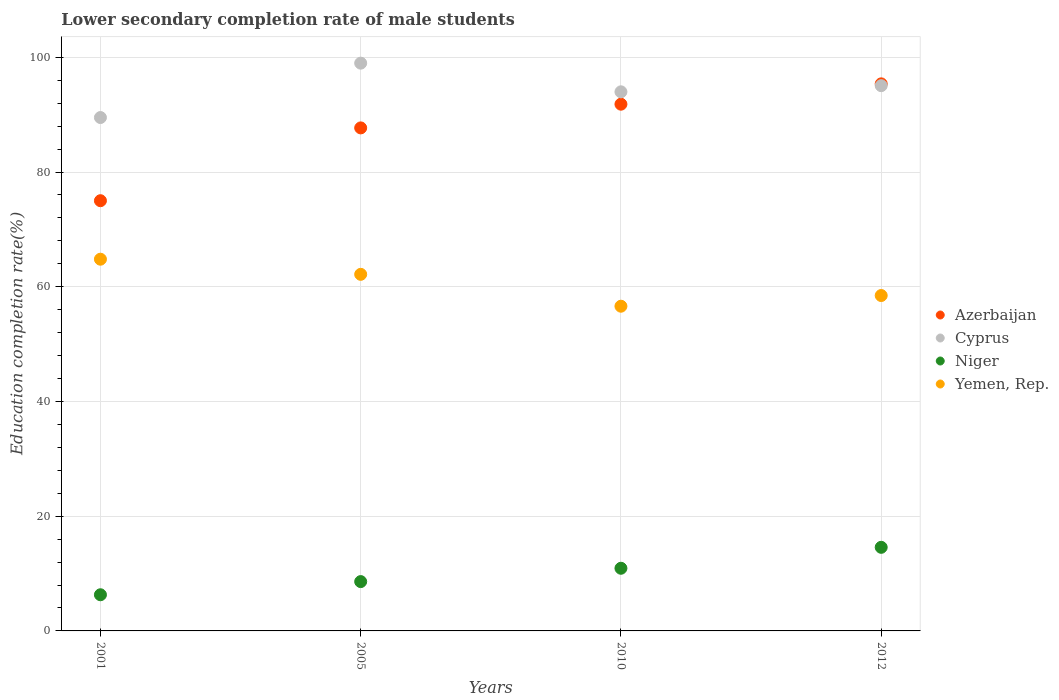What is the lower secondary completion rate of male students in Cyprus in 2001?
Give a very brief answer. 89.5. Across all years, what is the maximum lower secondary completion rate of male students in Yemen, Rep.?
Offer a very short reply. 64.8. Across all years, what is the minimum lower secondary completion rate of male students in Yemen, Rep.?
Ensure brevity in your answer.  56.61. In which year was the lower secondary completion rate of male students in Niger maximum?
Offer a very short reply. 2012. In which year was the lower secondary completion rate of male students in Yemen, Rep. minimum?
Your answer should be compact. 2010. What is the total lower secondary completion rate of male students in Yemen, Rep. in the graph?
Give a very brief answer. 242.05. What is the difference between the lower secondary completion rate of male students in Yemen, Rep. in 2005 and that in 2010?
Offer a very short reply. 5.56. What is the difference between the lower secondary completion rate of male students in Cyprus in 2005 and the lower secondary completion rate of male students in Yemen, Rep. in 2012?
Make the answer very short. 40.51. What is the average lower secondary completion rate of male students in Cyprus per year?
Offer a very short reply. 94.38. In the year 2005, what is the difference between the lower secondary completion rate of male students in Niger and lower secondary completion rate of male students in Cyprus?
Provide a short and direct response. -90.38. What is the ratio of the lower secondary completion rate of male students in Niger in 2001 to that in 2012?
Make the answer very short. 0.43. Is the difference between the lower secondary completion rate of male students in Niger in 2001 and 2010 greater than the difference between the lower secondary completion rate of male students in Cyprus in 2001 and 2010?
Give a very brief answer. No. What is the difference between the highest and the second highest lower secondary completion rate of male students in Azerbaijan?
Provide a short and direct response. 3.55. What is the difference between the highest and the lowest lower secondary completion rate of male students in Yemen, Rep.?
Your response must be concise. 8.2. In how many years, is the lower secondary completion rate of male students in Cyprus greater than the average lower secondary completion rate of male students in Cyprus taken over all years?
Offer a terse response. 2. Is the sum of the lower secondary completion rate of male students in Niger in 2010 and 2012 greater than the maximum lower secondary completion rate of male students in Azerbaijan across all years?
Provide a succinct answer. No. Is it the case that in every year, the sum of the lower secondary completion rate of male students in Yemen, Rep. and lower secondary completion rate of male students in Azerbaijan  is greater than the sum of lower secondary completion rate of male students in Cyprus and lower secondary completion rate of male students in Niger?
Keep it short and to the point. No. Does the lower secondary completion rate of male students in Cyprus monotonically increase over the years?
Make the answer very short. No. How many dotlines are there?
Offer a terse response. 4. How many years are there in the graph?
Give a very brief answer. 4. Does the graph contain any zero values?
Offer a very short reply. No. Does the graph contain grids?
Offer a terse response. Yes. Where does the legend appear in the graph?
Give a very brief answer. Center right. How many legend labels are there?
Provide a succinct answer. 4. How are the legend labels stacked?
Your answer should be compact. Vertical. What is the title of the graph?
Give a very brief answer. Lower secondary completion rate of male students. What is the label or title of the X-axis?
Ensure brevity in your answer.  Years. What is the label or title of the Y-axis?
Offer a very short reply. Education completion rate(%). What is the Education completion rate(%) in Cyprus in 2001?
Make the answer very short. 89.5. What is the Education completion rate(%) of Niger in 2001?
Provide a short and direct response. 6.3. What is the Education completion rate(%) of Yemen, Rep. in 2001?
Provide a short and direct response. 64.8. What is the Education completion rate(%) in Azerbaijan in 2005?
Offer a terse response. 87.69. What is the Education completion rate(%) of Cyprus in 2005?
Offer a very short reply. 98.98. What is the Education completion rate(%) of Niger in 2005?
Offer a very short reply. 8.6. What is the Education completion rate(%) of Yemen, Rep. in 2005?
Provide a short and direct response. 62.17. What is the Education completion rate(%) in Azerbaijan in 2010?
Provide a short and direct response. 91.83. What is the Education completion rate(%) in Cyprus in 2010?
Provide a short and direct response. 93.98. What is the Education completion rate(%) in Niger in 2010?
Your answer should be very brief. 10.92. What is the Education completion rate(%) in Yemen, Rep. in 2010?
Keep it short and to the point. 56.61. What is the Education completion rate(%) in Azerbaijan in 2012?
Ensure brevity in your answer.  95.37. What is the Education completion rate(%) of Cyprus in 2012?
Keep it short and to the point. 95.06. What is the Education completion rate(%) in Niger in 2012?
Provide a succinct answer. 14.57. What is the Education completion rate(%) of Yemen, Rep. in 2012?
Offer a very short reply. 58.47. Across all years, what is the maximum Education completion rate(%) of Azerbaijan?
Your answer should be very brief. 95.37. Across all years, what is the maximum Education completion rate(%) of Cyprus?
Keep it short and to the point. 98.98. Across all years, what is the maximum Education completion rate(%) in Niger?
Your answer should be very brief. 14.57. Across all years, what is the maximum Education completion rate(%) of Yemen, Rep.?
Your answer should be very brief. 64.8. Across all years, what is the minimum Education completion rate(%) in Cyprus?
Offer a very short reply. 89.5. Across all years, what is the minimum Education completion rate(%) in Niger?
Offer a terse response. 6.3. Across all years, what is the minimum Education completion rate(%) of Yemen, Rep.?
Make the answer very short. 56.61. What is the total Education completion rate(%) of Azerbaijan in the graph?
Keep it short and to the point. 349.89. What is the total Education completion rate(%) in Cyprus in the graph?
Your answer should be compact. 377.52. What is the total Education completion rate(%) of Niger in the graph?
Ensure brevity in your answer.  40.4. What is the total Education completion rate(%) of Yemen, Rep. in the graph?
Offer a very short reply. 242.05. What is the difference between the Education completion rate(%) in Azerbaijan in 2001 and that in 2005?
Provide a short and direct response. -12.69. What is the difference between the Education completion rate(%) of Cyprus in 2001 and that in 2005?
Provide a short and direct response. -9.48. What is the difference between the Education completion rate(%) in Niger in 2001 and that in 2005?
Keep it short and to the point. -2.29. What is the difference between the Education completion rate(%) in Yemen, Rep. in 2001 and that in 2005?
Offer a very short reply. 2.64. What is the difference between the Education completion rate(%) in Azerbaijan in 2001 and that in 2010?
Give a very brief answer. -16.83. What is the difference between the Education completion rate(%) of Cyprus in 2001 and that in 2010?
Ensure brevity in your answer.  -4.48. What is the difference between the Education completion rate(%) of Niger in 2001 and that in 2010?
Give a very brief answer. -4.62. What is the difference between the Education completion rate(%) of Yemen, Rep. in 2001 and that in 2010?
Provide a short and direct response. 8.2. What is the difference between the Education completion rate(%) in Azerbaijan in 2001 and that in 2012?
Keep it short and to the point. -20.37. What is the difference between the Education completion rate(%) of Cyprus in 2001 and that in 2012?
Keep it short and to the point. -5.55. What is the difference between the Education completion rate(%) in Niger in 2001 and that in 2012?
Keep it short and to the point. -8.27. What is the difference between the Education completion rate(%) of Yemen, Rep. in 2001 and that in 2012?
Make the answer very short. 6.33. What is the difference between the Education completion rate(%) of Azerbaijan in 2005 and that in 2010?
Make the answer very short. -4.13. What is the difference between the Education completion rate(%) of Cyprus in 2005 and that in 2010?
Offer a terse response. 5. What is the difference between the Education completion rate(%) in Niger in 2005 and that in 2010?
Make the answer very short. -2.33. What is the difference between the Education completion rate(%) of Yemen, Rep. in 2005 and that in 2010?
Make the answer very short. 5.56. What is the difference between the Education completion rate(%) in Azerbaijan in 2005 and that in 2012?
Give a very brief answer. -7.68. What is the difference between the Education completion rate(%) in Cyprus in 2005 and that in 2012?
Your answer should be compact. 3.92. What is the difference between the Education completion rate(%) in Niger in 2005 and that in 2012?
Ensure brevity in your answer.  -5.98. What is the difference between the Education completion rate(%) in Yemen, Rep. in 2005 and that in 2012?
Your response must be concise. 3.69. What is the difference between the Education completion rate(%) in Azerbaijan in 2010 and that in 2012?
Offer a terse response. -3.55. What is the difference between the Education completion rate(%) in Cyprus in 2010 and that in 2012?
Your answer should be compact. -1.07. What is the difference between the Education completion rate(%) of Niger in 2010 and that in 2012?
Keep it short and to the point. -3.65. What is the difference between the Education completion rate(%) of Yemen, Rep. in 2010 and that in 2012?
Your answer should be very brief. -1.86. What is the difference between the Education completion rate(%) of Azerbaijan in 2001 and the Education completion rate(%) of Cyprus in 2005?
Ensure brevity in your answer.  -23.98. What is the difference between the Education completion rate(%) in Azerbaijan in 2001 and the Education completion rate(%) in Niger in 2005?
Make the answer very short. 66.4. What is the difference between the Education completion rate(%) of Azerbaijan in 2001 and the Education completion rate(%) of Yemen, Rep. in 2005?
Ensure brevity in your answer.  12.83. What is the difference between the Education completion rate(%) of Cyprus in 2001 and the Education completion rate(%) of Niger in 2005?
Provide a short and direct response. 80.9. What is the difference between the Education completion rate(%) of Cyprus in 2001 and the Education completion rate(%) of Yemen, Rep. in 2005?
Your answer should be very brief. 27.34. What is the difference between the Education completion rate(%) in Niger in 2001 and the Education completion rate(%) in Yemen, Rep. in 2005?
Provide a succinct answer. -55.86. What is the difference between the Education completion rate(%) in Azerbaijan in 2001 and the Education completion rate(%) in Cyprus in 2010?
Offer a very short reply. -18.98. What is the difference between the Education completion rate(%) in Azerbaijan in 2001 and the Education completion rate(%) in Niger in 2010?
Your answer should be compact. 64.08. What is the difference between the Education completion rate(%) in Azerbaijan in 2001 and the Education completion rate(%) in Yemen, Rep. in 2010?
Make the answer very short. 18.39. What is the difference between the Education completion rate(%) in Cyprus in 2001 and the Education completion rate(%) in Niger in 2010?
Offer a very short reply. 78.58. What is the difference between the Education completion rate(%) in Cyprus in 2001 and the Education completion rate(%) in Yemen, Rep. in 2010?
Give a very brief answer. 32.89. What is the difference between the Education completion rate(%) of Niger in 2001 and the Education completion rate(%) of Yemen, Rep. in 2010?
Offer a very short reply. -50.3. What is the difference between the Education completion rate(%) in Azerbaijan in 2001 and the Education completion rate(%) in Cyprus in 2012?
Your answer should be very brief. -20.06. What is the difference between the Education completion rate(%) in Azerbaijan in 2001 and the Education completion rate(%) in Niger in 2012?
Give a very brief answer. 60.43. What is the difference between the Education completion rate(%) in Azerbaijan in 2001 and the Education completion rate(%) in Yemen, Rep. in 2012?
Provide a short and direct response. 16.53. What is the difference between the Education completion rate(%) in Cyprus in 2001 and the Education completion rate(%) in Niger in 2012?
Offer a very short reply. 74.93. What is the difference between the Education completion rate(%) in Cyprus in 2001 and the Education completion rate(%) in Yemen, Rep. in 2012?
Provide a short and direct response. 31.03. What is the difference between the Education completion rate(%) of Niger in 2001 and the Education completion rate(%) of Yemen, Rep. in 2012?
Offer a very short reply. -52.17. What is the difference between the Education completion rate(%) of Azerbaijan in 2005 and the Education completion rate(%) of Cyprus in 2010?
Ensure brevity in your answer.  -6.29. What is the difference between the Education completion rate(%) in Azerbaijan in 2005 and the Education completion rate(%) in Niger in 2010?
Make the answer very short. 76.77. What is the difference between the Education completion rate(%) in Azerbaijan in 2005 and the Education completion rate(%) in Yemen, Rep. in 2010?
Give a very brief answer. 31.09. What is the difference between the Education completion rate(%) of Cyprus in 2005 and the Education completion rate(%) of Niger in 2010?
Your response must be concise. 88.06. What is the difference between the Education completion rate(%) of Cyprus in 2005 and the Education completion rate(%) of Yemen, Rep. in 2010?
Make the answer very short. 42.37. What is the difference between the Education completion rate(%) of Niger in 2005 and the Education completion rate(%) of Yemen, Rep. in 2010?
Provide a short and direct response. -48.01. What is the difference between the Education completion rate(%) of Azerbaijan in 2005 and the Education completion rate(%) of Cyprus in 2012?
Your answer should be compact. -7.36. What is the difference between the Education completion rate(%) in Azerbaijan in 2005 and the Education completion rate(%) in Niger in 2012?
Your answer should be compact. 73.12. What is the difference between the Education completion rate(%) in Azerbaijan in 2005 and the Education completion rate(%) in Yemen, Rep. in 2012?
Your response must be concise. 29.22. What is the difference between the Education completion rate(%) in Cyprus in 2005 and the Education completion rate(%) in Niger in 2012?
Your response must be concise. 84.41. What is the difference between the Education completion rate(%) of Cyprus in 2005 and the Education completion rate(%) of Yemen, Rep. in 2012?
Provide a short and direct response. 40.51. What is the difference between the Education completion rate(%) in Niger in 2005 and the Education completion rate(%) in Yemen, Rep. in 2012?
Offer a terse response. -49.87. What is the difference between the Education completion rate(%) of Azerbaijan in 2010 and the Education completion rate(%) of Cyprus in 2012?
Keep it short and to the point. -3.23. What is the difference between the Education completion rate(%) in Azerbaijan in 2010 and the Education completion rate(%) in Niger in 2012?
Keep it short and to the point. 77.25. What is the difference between the Education completion rate(%) of Azerbaijan in 2010 and the Education completion rate(%) of Yemen, Rep. in 2012?
Offer a terse response. 33.36. What is the difference between the Education completion rate(%) of Cyprus in 2010 and the Education completion rate(%) of Niger in 2012?
Give a very brief answer. 79.41. What is the difference between the Education completion rate(%) of Cyprus in 2010 and the Education completion rate(%) of Yemen, Rep. in 2012?
Keep it short and to the point. 35.51. What is the difference between the Education completion rate(%) in Niger in 2010 and the Education completion rate(%) in Yemen, Rep. in 2012?
Keep it short and to the point. -47.55. What is the average Education completion rate(%) of Azerbaijan per year?
Give a very brief answer. 87.47. What is the average Education completion rate(%) of Cyprus per year?
Provide a short and direct response. 94.38. What is the average Education completion rate(%) of Niger per year?
Offer a very short reply. 10.1. What is the average Education completion rate(%) of Yemen, Rep. per year?
Provide a short and direct response. 60.51. In the year 2001, what is the difference between the Education completion rate(%) in Azerbaijan and Education completion rate(%) in Cyprus?
Give a very brief answer. -14.5. In the year 2001, what is the difference between the Education completion rate(%) of Azerbaijan and Education completion rate(%) of Niger?
Provide a short and direct response. 68.7. In the year 2001, what is the difference between the Education completion rate(%) in Azerbaijan and Education completion rate(%) in Yemen, Rep.?
Ensure brevity in your answer.  10.2. In the year 2001, what is the difference between the Education completion rate(%) of Cyprus and Education completion rate(%) of Niger?
Make the answer very short. 83.2. In the year 2001, what is the difference between the Education completion rate(%) of Cyprus and Education completion rate(%) of Yemen, Rep.?
Make the answer very short. 24.7. In the year 2001, what is the difference between the Education completion rate(%) of Niger and Education completion rate(%) of Yemen, Rep.?
Your answer should be compact. -58.5. In the year 2005, what is the difference between the Education completion rate(%) of Azerbaijan and Education completion rate(%) of Cyprus?
Offer a very short reply. -11.29. In the year 2005, what is the difference between the Education completion rate(%) in Azerbaijan and Education completion rate(%) in Niger?
Keep it short and to the point. 79.1. In the year 2005, what is the difference between the Education completion rate(%) in Azerbaijan and Education completion rate(%) in Yemen, Rep.?
Offer a terse response. 25.53. In the year 2005, what is the difference between the Education completion rate(%) in Cyprus and Education completion rate(%) in Niger?
Keep it short and to the point. 90.38. In the year 2005, what is the difference between the Education completion rate(%) in Cyprus and Education completion rate(%) in Yemen, Rep.?
Keep it short and to the point. 36.81. In the year 2005, what is the difference between the Education completion rate(%) of Niger and Education completion rate(%) of Yemen, Rep.?
Offer a very short reply. -53.57. In the year 2010, what is the difference between the Education completion rate(%) of Azerbaijan and Education completion rate(%) of Cyprus?
Ensure brevity in your answer.  -2.16. In the year 2010, what is the difference between the Education completion rate(%) in Azerbaijan and Education completion rate(%) in Niger?
Your answer should be very brief. 80.9. In the year 2010, what is the difference between the Education completion rate(%) of Azerbaijan and Education completion rate(%) of Yemen, Rep.?
Your answer should be compact. 35.22. In the year 2010, what is the difference between the Education completion rate(%) of Cyprus and Education completion rate(%) of Niger?
Provide a short and direct response. 83.06. In the year 2010, what is the difference between the Education completion rate(%) in Cyprus and Education completion rate(%) in Yemen, Rep.?
Your answer should be very brief. 37.38. In the year 2010, what is the difference between the Education completion rate(%) in Niger and Education completion rate(%) in Yemen, Rep.?
Provide a succinct answer. -45.68. In the year 2012, what is the difference between the Education completion rate(%) in Azerbaijan and Education completion rate(%) in Cyprus?
Provide a succinct answer. 0.32. In the year 2012, what is the difference between the Education completion rate(%) of Azerbaijan and Education completion rate(%) of Niger?
Give a very brief answer. 80.8. In the year 2012, what is the difference between the Education completion rate(%) in Azerbaijan and Education completion rate(%) in Yemen, Rep.?
Your response must be concise. 36.9. In the year 2012, what is the difference between the Education completion rate(%) of Cyprus and Education completion rate(%) of Niger?
Offer a terse response. 80.48. In the year 2012, what is the difference between the Education completion rate(%) in Cyprus and Education completion rate(%) in Yemen, Rep.?
Provide a succinct answer. 36.58. In the year 2012, what is the difference between the Education completion rate(%) in Niger and Education completion rate(%) in Yemen, Rep.?
Keep it short and to the point. -43.9. What is the ratio of the Education completion rate(%) in Azerbaijan in 2001 to that in 2005?
Your response must be concise. 0.86. What is the ratio of the Education completion rate(%) of Cyprus in 2001 to that in 2005?
Provide a succinct answer. 0.9. What is the ratio of the Education completion rate(%) of Niger in 2001 to that in 2005?
Offer a very short reply. 0.73. What is the ratio of the Education completion rate(%) of Yemen, Rep. in 2001 to that in 2005?
Give a very brief answer. 1.04. What is the ratio of the Education completion rate(%) of Azerbaijan in 2001 to that in 2010?
Keep it short and to the point. 0.82. What is the ratio of the Education completion rate(%) of Cyprus in 2001 to that in 2010?
Offer a very short reply. 0.95. What is the ratio of the Education completion rate(%) of Niger in 2001 to that in 2010?
Your answer should be compact. 0.58. What is the ratio of the Education completion rate(%) of Yemen, Rep. in 2001 to that in 2010?
Offer a very short reply. 1.14. What is the ratio of the Education completion rate(%) in Azerbaijan in 2001 to that in 2012?
Ensure brevity in your answer.  0.79. What is the ratio of the Education completion rate(%) of Cyprus in 2001 to that in 2012?
Provide a succinct answer. 0.94. What is the ratio of the Education completion rate(%) of Niger in 2001 to that in 2012?
Your response must be concise. 0.43. What is the ratio of the Education completion rate(%) of Yemen, Rep. in 2001 to that in 2012?
Your response must be concise. 1.11. What is the ratio of the Education completion rate(%) of Azerbaijan in 2005 to that in 2010?
Your response must be concise. 0.95. What is the ratio of the Education completion rate(%) of Cyprus in 2005 to that in 2010?
Offer a very short reply. 1.05. What is the ratio of the Education completion rate(%) of Niger in 2005 to that in 2010?
Your answer should be very brief. 0.79. What is the ratio of the Education completion rate(%) in Yemen, Rep. in 2005 to that in 2010?
Your response must be concise. 1.1. What is the ratio of the Education completion rate(%) in Azerbaijan in 2005 to that in 2012?
Ensure brevity in your answer.  0.92. What is the ratio of the Education completion rate(%) in Cyprus in 2005 to that in 2012?
Offer a very short reply. 1.04. What is the ratio of the Education completion rate(%) in Niger in 2005 to that in 2012?
Your answer should be very brief. 0.59. What is the ratio of the Education completion rate(%) in Yemen, Rep. in 2005 to that in 2012?
Give a very brief answer. 1.06. What is the ratio of the Education completion rate(%) of Azerbaijan in 2010 to that in 2012?
Ensure brevity in your answer.  0.96. What is the ratio of the Education completion rate(%) in Cyprus in 2010 to that in 2012?
Your answer should be compact. 0.99. What is the ratio of the Education completion rate(%) in Niger in 2010 to that in 2012?
Provide a short and direct response. 0.75. What is the ratio of the Education completion rate(%) in Yemen, Rep. in 2010 to that in 2012?
Keep it short and to the point. 0.97. What is the difference between the highest and the second highest Education completion rate(%) in Azerbaijan?
Give a very brief answer. 3.55. What is the difference between the highest and the second highest Education completion rate(%) of Cyprus?
Offer a very short reply. 3.92. What is the difference between the highest and the second highest Education completion rate(%) of Niger?
Provide a succinct answer. 3.65. What is the difference between the highest and the second highest Education completion rate(%) in Yemen, Rep.?
Your answer should be compact. 2.64. What is the difference between the highest and the lowest Education completion rate(%) of Azerbaijan?
Your answer should be very brief. 20.37. What is the difference between the highest and the lowest Education completion rate(%) in Cyprus?
Your response must be concise. 9.48. What is the difference between the highest and the lowest Education completion rate(%) of Niger?
Your answer should be very brief. 8.27. What is the difference between the highest and the lowest Education completion rate(%) of Yemen, Rep.?
Make the answer very short. 8.2. 